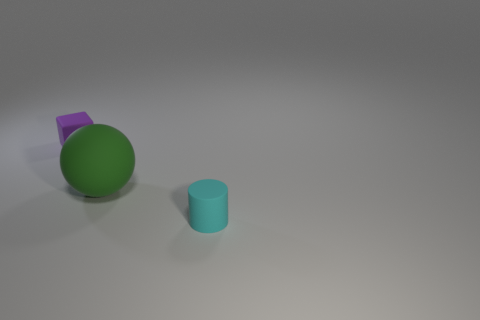How many rubber things are small purple balls or tiny cyan things?
Give a very brief answer. 1. How many cylinders are there?
Provide a succinct answer. 1. What is the color of the other matte object that is the same size as the purple object?
Keep it short and to the point. Cyan. Do the cyan matte cylinder and the block have the same size?
Give a very brief answer. Yes. Is the size of the rubber block the same as the object that is right of the large green matte sphere?
Your response must be concise. Yes. There is a object that is both to the left of the tiny cyan cylinder and in front of the purple matte thing; what color is it?
Keep it short and to the point. Green. Is the number of big rubber objects that are in front of the small purple matte cube greater than the number of tiny rubber cubes that are in front of the small cyan matte thing?
Provide a short and direct response. Yes. The ball that is the same material as the purple thing is what size?
Keep it short and to the point. Large. There is a small matte thing in front of the tiny block; how many small matte things are behind it?
Offer a terse response. 1. Are there any other tiny rubber things that have the same shape as the tiny cyan object?
Give a very brief answer. No. 